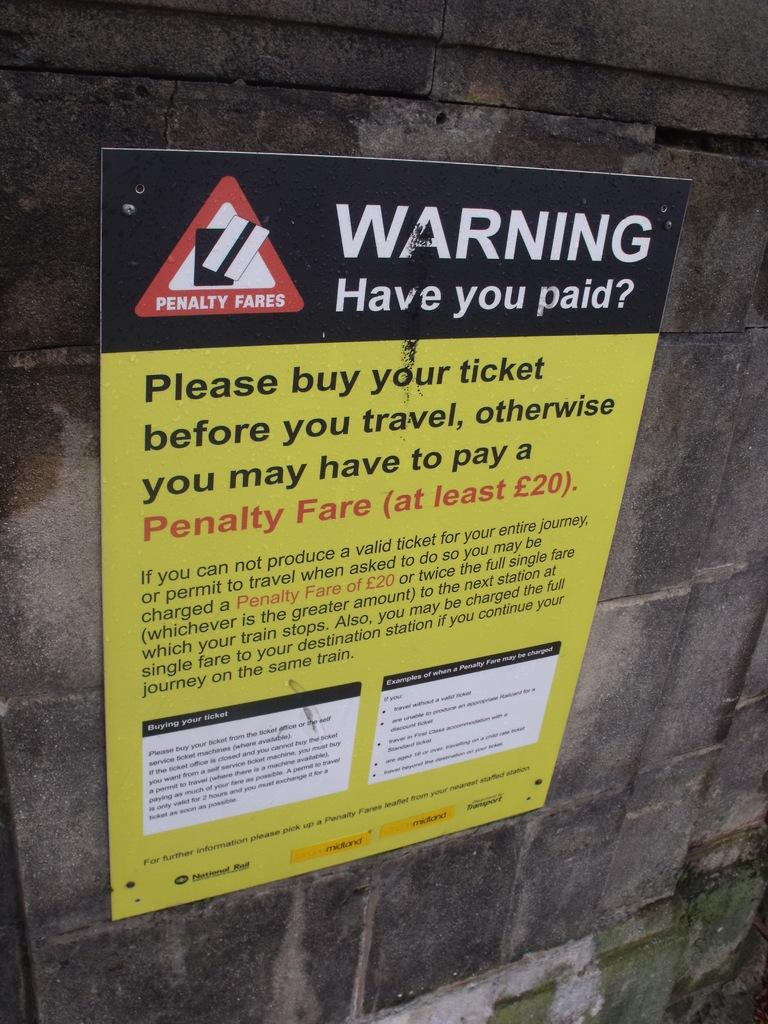<image>
Summarize the visual content of the image. A sign warns that there's a penalty fare for failing to buy your ticket before you travel. 